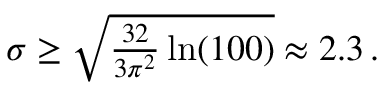Convert formula to latex. <formula><loc_0><loc_0><loc_500><loc_500>\begin{array} { r } { \sigma \geq \sqrt { \frac { 3 2 } { 3 \pi ^ { 2 } } \ln ( 1 0 0 ) } \approx 2 . 3 \, . } \end{array}</formula> 